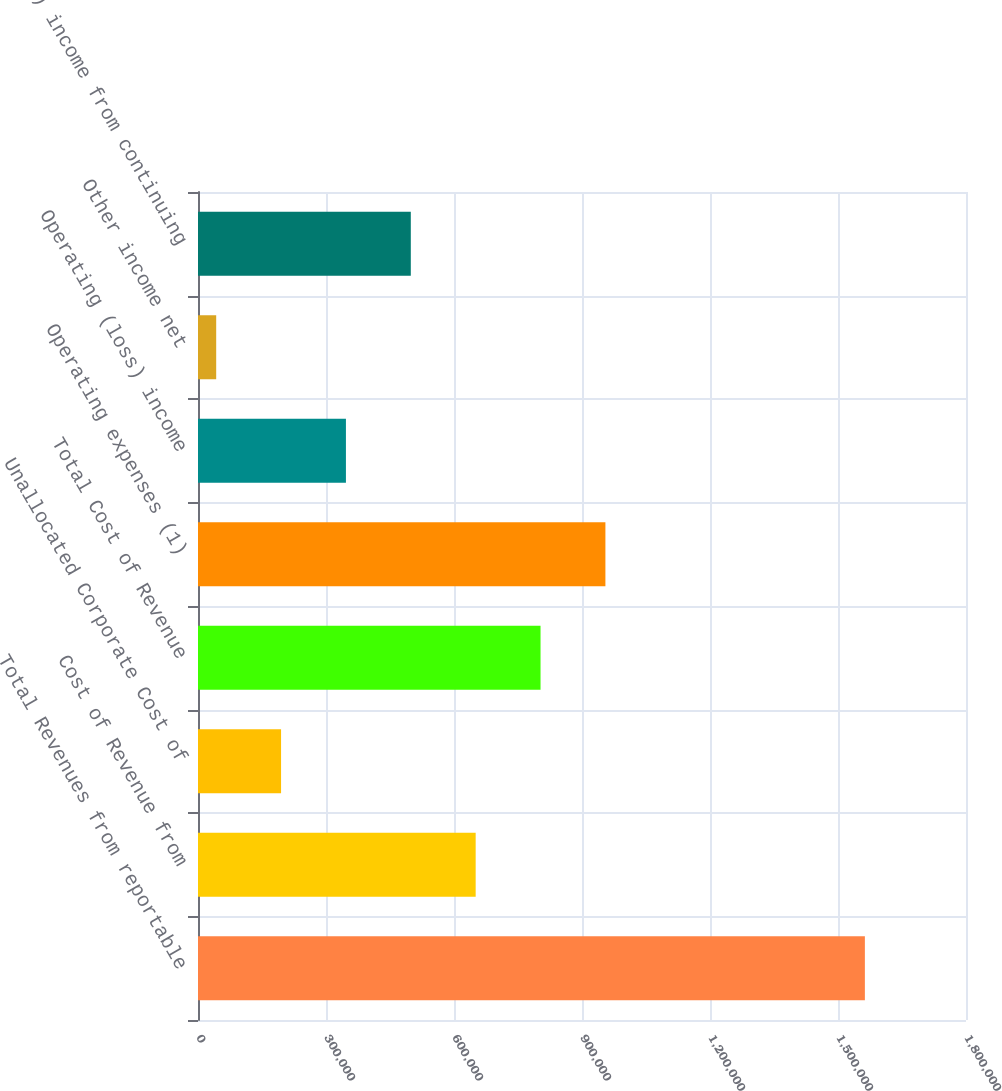<chart> <loc_0><loc_0><loc_500><loc_500><bar_chart><fcel>Total Revenues from reportable<fcel>Cost of Revenue from<fcel>Unallocated Corporate Cost of<fcel>Total Cost of Revenue<fcel>Operating expenses (1)<fcel>Operating (loss) income<fcel>Other income net<fcel>(Loss) income from continuing<nl><fcel>1.563e+06<fcel>650785<fcel>194678<fcel>802820<fcel>954856<fcel>346714<fcel>42643<fcel>498750<nl></chart> 